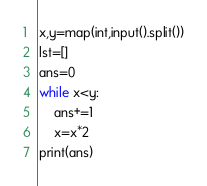Convert code to text. <code><loc_0><loc_0><loc_500><loc_500><_Python_>x,y=map(int,input().split())
lst=[]
ans=0
while x<y:
    ans+=1
    x=x*2
print(ans)</code> 